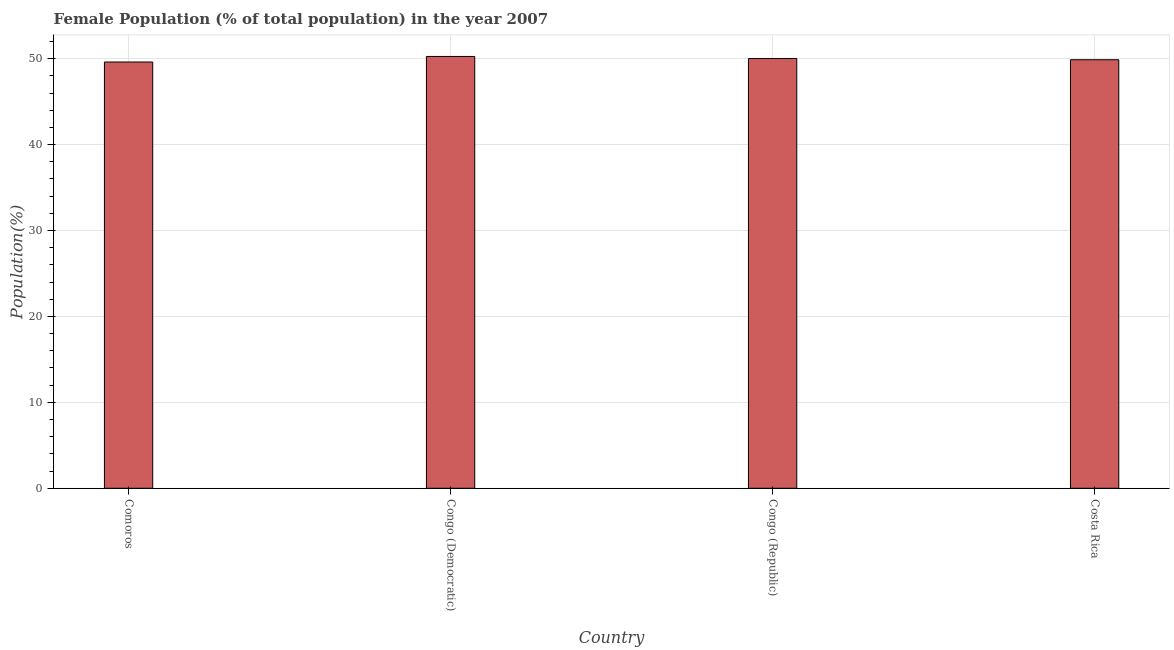Does the graph contain any zero values?
Offer a very short reply. No. Does the graph contain grids?
Offer a terse response. Yes. What is the title of the graph?
Ensure brevity in your answer.  Female Population (% of total population) in the year 2007. What is the label or title of the X-axis?
Give a very brief answer. Country. What is the label or title of the Y-axis?
Offer a very short reply. Population(%). What is the female population in Congo (Democratic)?
Offer a very short reply. 50.26. Across all countries, what is the maximum female population?
Offer a very short reply. 50.26. Across all countries, what is the minimum female population?
Your answer should be compact. 49.61. In which country was the female population maximum?
Offer a very short reply. Congo (Democratic). In which country was the female population minimum?
Provide a short and direct response. Comoros. What is the sum of the female population?
Offer a very short reply. 199.78. What is the difference between the female population in Comoros and Costa Rica?
Offer a very short reply. -0.26. What is the average female population per country?
Offer a very short reply. 49.95. What is the median female population?
Provide a short and direct response. 49.95. In how many countries, is the female population greater than 36 %?
Keep it short and to the point. 4. Is the female population in Congo (Democratic) less than that in Costa Rica?
Offer a very short reply. No. Is the difference between the female population in Comoros and Costa Rica greater than the difference between any two countries?
Your response must be concise. No. What is the difference between the highest and the second highest female population?
Provide a short and direct response. 0.23. Is the sum of the female population in Comoros and Congo (Republic) greater than the maximum female population across all countries?
Provide a succinct answer. Yes. What is the difference between the highest and the lowest female population?
Keep it short and to the point. 0.65. How many bars are there?
Provide a short and direct response. 4. How many countries are there in the graph?
Keep it short and to the point. 4. What is the difference between two consecutive major ticks on the Y-axis?
Your answer should be compact. 10. Are the values on the major ticks of Y-axis written in scientific E-notation?
Make the answer very short. No. What is the Population(%) of Comoros?
Offer a terse response. 49.61. What is the Population(%) in Congo (Democratic)?
Give a very brief answer. 50.26. What is the Population(%) of Congo (Republic)?
Make the answer very short. 50.03. What is the Population(%) in Costa Rica?
Provide a short and direct response. 49.88. What is the difference between the Population(%) in Comoros and Congo (Democratic)?
Give a very brief answer. -0.65. What is the difference between the Population(%) in Comoros and Congo (Republic)?
Offer a very short reply. -0.41. What is the difference between the Population(%) in Comoros and Costa Rica?
Keep it short and to the point. -0.26. What is the difference between the Population(%) in Congo (Democratic) and Congo (Republic)?
Your answer should be very brief. 0.23. What is the difference between the Population(%) in Congo (Democratic) and Costa Rica?
Ensure brevity in your answer.  0.38. What is the difference between the Population(%) in Congo (Republic) and Costa Rica?
Make the answer very short. 0.15. What is the ratio of the Population(%) in Comoros to that in Congo (Democratic)?
Your response must be concise. 0.99. What is the ratio of the Population(%) in Comoros to that in Costa Rica?
Your answer should be very brief. 0.99. What is the ratio of the Population(%) in Congo (Democratic) to that in Congo (Republic)?
Your answer should be very brief. 1. What is the ratio of the Population(%) in Congo (Republic) to that in Costa Rica?
Offer a very short reply. 1. 